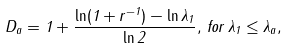Convert formula to latex. <formula><loc_0><loc_0><loc_500><loc_500>D _ { a } = 1 + \frac { \ln ( 1 + r ^ { - 1 } ) - \ln \lambda _ { 1 } } { \ln 2 } , \, f o r \, \lambda _ { 1 } \leq \lambda _ { a } ,</formula> 